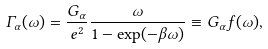<formula> <loc_0><loc_0><loc_500><loc_500>\Gamma _ { \alpha } ( \omega ) = \frac { G _ { \alpha } } { e ^ { 2 } } \frac { \omega } { 1 - \exp ( - \beta \omega ) } \equiv G _ { \alpha } f ( \omega ) ,</formula> 